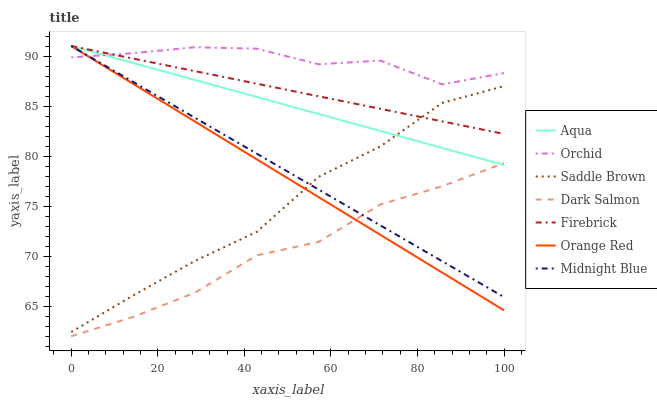Does Dark Salmon have the minimum area under the curve?
Answer yes or no. Yes. Does Orchid have the maximum area under the curve?
Answer yes or no. Yes. Does Firebrick have the minimum area under the curve?
Answer yes or no. No. Does Firebrick have the maximum area under the curve?
Answer yes or no. No. Is Firebrick the smoothest?
Answer yes or no. Yes. Is Orchid the roughest?
Answer yes or no. Yes. Is Aqua the smoothest?
Answer yes or no. No. Is Aqua the roughest?
Answer yes or no. No. Does Dark Salmon have the lowest value?
Answer yes or no. Yes. Does Firebrick have the lowest value?
Answer yes or no. No. Does Orange Red have the highest value?
Answer yes or no. Yes. Does Dark Salmon have the highest value?
Answer yes or no. No. Is Dark Salmon less than Firebrick?
Answer yes or no. Yes. Is Saddle Brown greater than Dark Salmon?
Answer yes or no. Yes. Does Orchid intersect Aqua?
Answer yes or no. Yes. Is Orchid less than Aqua?
Answer yes or no. No. Is Orchid greater than Aqua?
Answer yes or no. No. Does Dark Salmon intersect Firebrick?
Answer yes or no. No. 